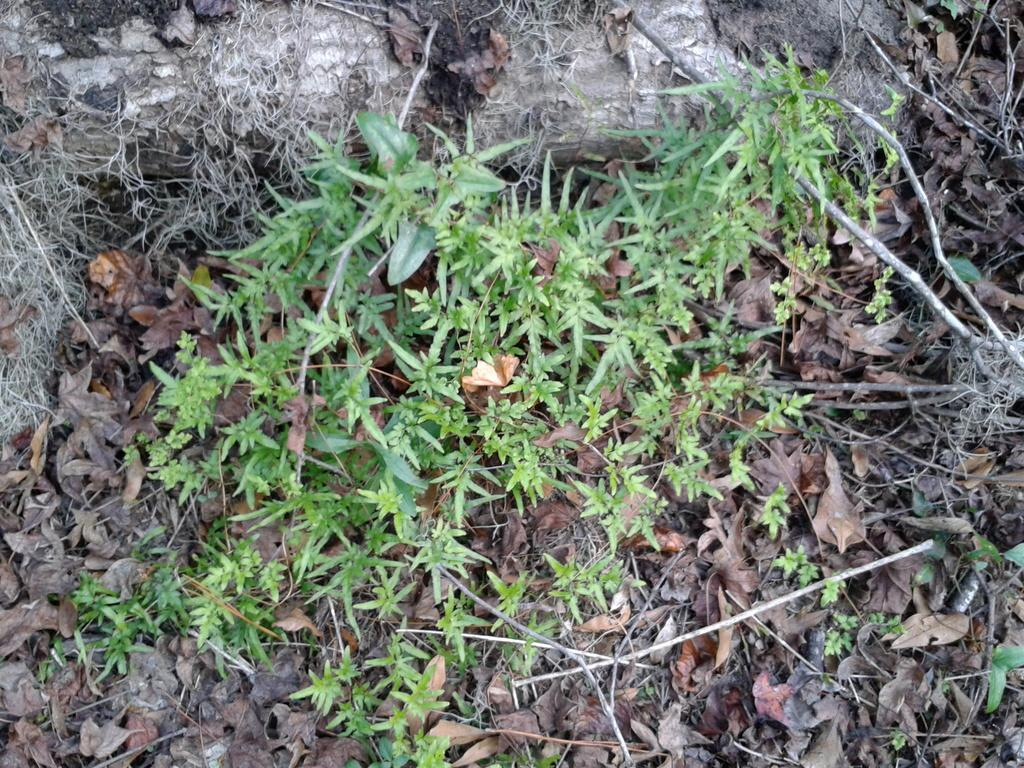What type of vegetation can be seen on the land in the image? There are small plants on the land in the image. What is the condition of the leaves in the image? Dry leaves are present in the image. What else can be seen in the image that is related to the plants? Dry stems are visible in the image. What type of throat condition can be seen in the image? There is no throat condition present in the image; it features small plants, dry leaves, and dry stems. Can you tell me how the machine is being used in the image? There is no machine present in the image. 